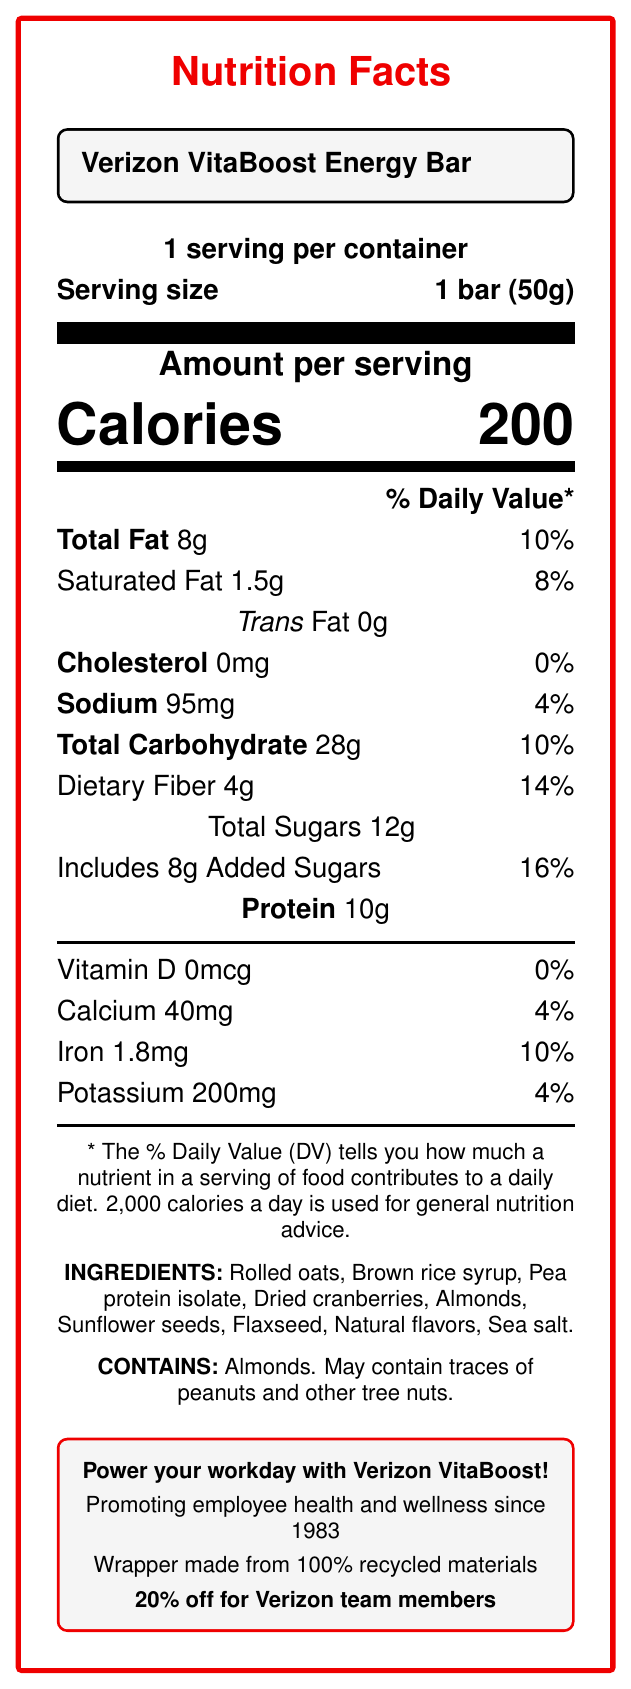What is the serving size of the Verizon VitaBoost Energy Bar? The serving size is clearly mentioned as "1 bar (50g)" on the label.
Answer: 1 bar (50g) How many calories are in one serving of the Verizon VitaBoost Energy Bar? The label states that there are 200 calories per serving.
Answer: 200 What percentage of the daily value of saturated fat does the energy bar contain? The label indicates that the saturated fat content is 1.5g, which is 8% of the daily value.
Answer: 8% How much iron is in the Verizon VitaBoost Energy Bar? The iron content is listed as 1.8mg on the label.
Answer: 1.8mg What is the total amount of sugars in the energy bar? The label mentions that the total sugars amount to 12g.
Answer: 12g How much dietary fiber does the snack contain? The dietary fiber content is specified as 4g on the label.
Answer: 4g Does the Verizon VitaBoost Energy Bar contain any trans fat? The label shows 0g for trans fat.
Answer: No What is the slogan mentioned on the Verizon VitaBoost Energy Bar? The slogan is written in bold text in a separate tcolorbox at the bottom.
Answer: Power your workday with Verizon VitaBoost! For Verizon employees, what is the discount on the energy bar? A. 15% B. 20% C. 25% D. 30% The label clearly states that Verizon team members receive 20% off.
Answer: B Which of the following ingredients is found in the energy bar? A. Peanuts B. Flaxseed C. Milk D. Eggs The ingredient list includes "Flaxseed", while Peanuts, Milk, and Eggs are not mentioned.
Answer: B Is the wrapper of the Verizon VitaBoost Energy Bar made from recycled materials? The label specifies that the wrapper is made from 100% recycled materials.
Answer: Yes Does the energy bar contain vitamin D? The label indicates that the vitamin D content is 0mcg, or 0% of the daily value.
Answer: No Summarize the main idea of the document. The document serves to inform consumers about the nutritional content and benefits of the energy bar, while also promoting the product's alignment with Verizon's health, wellness, and sustainability values. It additionally offers a discount for Verizon employees.
Answer: The document provides detailed nutrition facts for the Verizon VitaBoost Energy Bar, including serving size, calorie content, and breakdown of various nutrients. It also lists the ingredients, allergen information, and highlights aspects like the product slogan, company values, sustainability, and employee discount. What is the main ingredient in the energy bar? The label lists multiple ingredients but does not indicate which one is the main ingredient.
Answer: Cannot be determined Does the energy bar contain any added sugars? The document specifies that there are 8g of added sugars, which is 16% of the daily value.
Answer: Yes What is the primary nutritional benefit promoted in the employee discount section? The label mentions "Promoting employee health and wellness since 1983" in the section highlighting the employee discount and other product benefits.
Answer: Employee health and wellness 